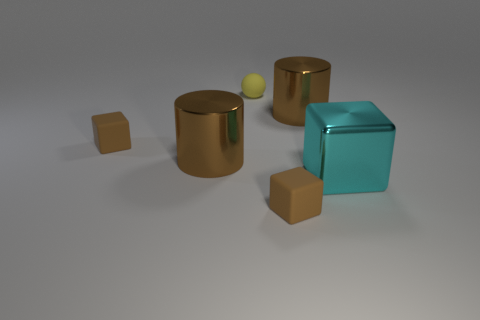Add 3 large brown shiny cylinders. How many objects exist? 9 Subtract all balls. How many objects are left? 5 Add 3 brown metal things. How many brown metal things are left? 5 Add 3 blocks. How many blocks exist? 6 Subtract 0 purple blocks. How many objects are left? 6 Subtract all cyan metal cubes. Subtract all large cyan matte cylinders. How many objects are left? 5 